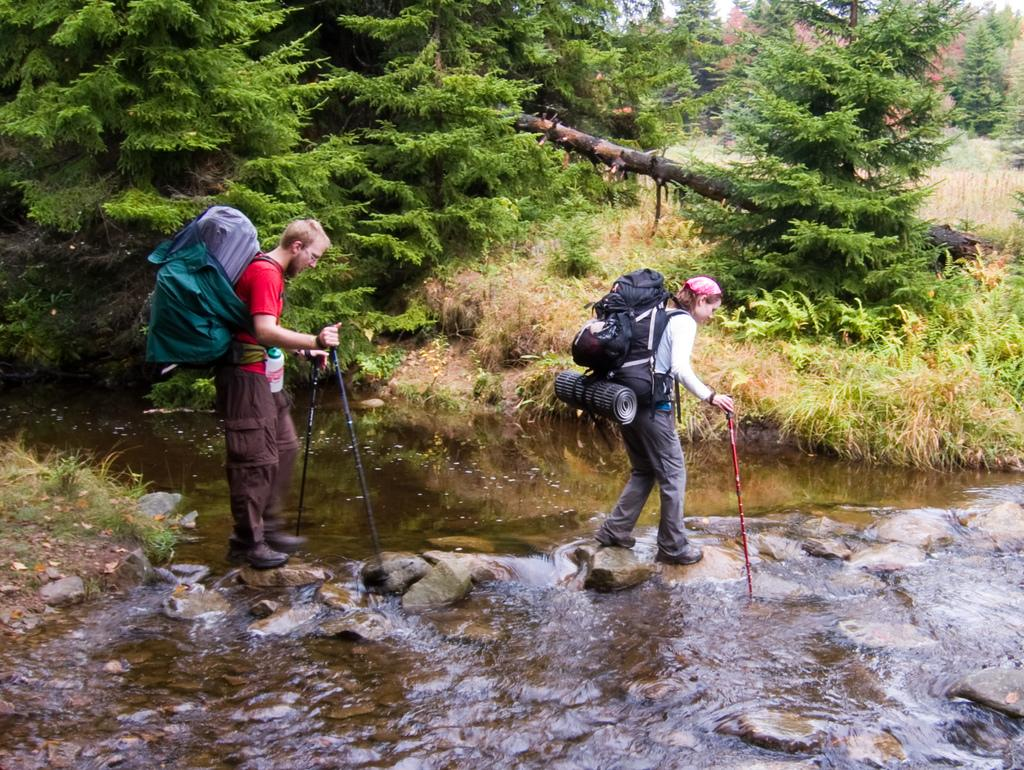Who can be seen in the foreground of the picture? There is a man and a woman in the foreground of the picture. What are the man and woman wearing? Both the man and woman are wearing backpacks. What are they holding in their hands? They are both holding sticks. What are they doing in the picture? They are crossing a river. What can be seen in the background of the picture? There are trees, grass, and water visible in the background of the picture. What type of dress is the man wearing in the picture? The man is not wearing a dress in the picture; he is wearing a backpack and holding a stick. 